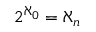Convert formula to latex. <formula><loc_0><loc_0><loc_500><loc_500>2 ^ { \aleph _ { 0 } } = \aleph _ { n }</formula> 